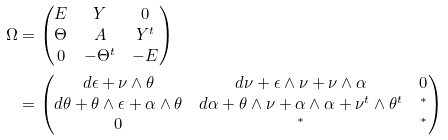Convert formula to latex. <formula><loc_0><loc_0><loc_500><loc_500>\Omega & = \begin{pmatrix} E & Y & 0 \\ \Theta & A & Y ^ { t } \\ 0 & - \Theta ^ { t } & - E \end{pmatrix} \\ & = \begin{pmatrix} d \epsilon + \nu \wedge \theta & d \nu + \epsilon \wedge \nu + \nu \wedge \alpha & 0 \\ d \theta + \theta \wedge \epsilon + \alpha \wedge \theta & d \alpha + \theta \wedge \nu + \alpha \wedge \alpha + \nu ^ { t } \wedge \theta ^ { t } & ^ { * } \\ 0 & ^ { * } & ^ { * } \end{pmatrix}</formula> 